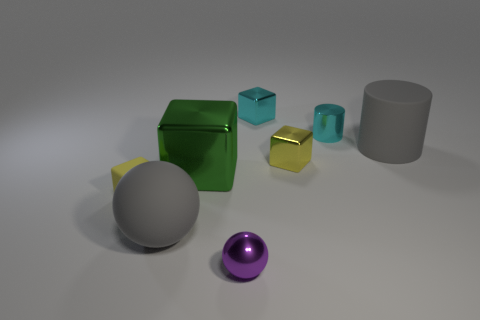Add 1 small red matte cubes. How many objects exist? 9 Subtract all cyan blocks. How many blocks are left? 3 Subtract all cyan cubes. How many cubes are left? 3 Subtract 1 cubes. How many cubes are left? 3 Subtract all brown cubes. Subtract all green spheres. How many cubes are left? 4 Subtract all brown cubes. How many brown cylinders are left? 0 Subtract all small purple matte cubes. Subtract all yellow things. How many objects are left? 6 Add 1 big gray matte cylinders. How many big gray matte cylinders are left? 2 Add 6 small matte blocks. How many small matte blocks exist? 7 Subtract 0 brown balls. How many objects are left? 8 